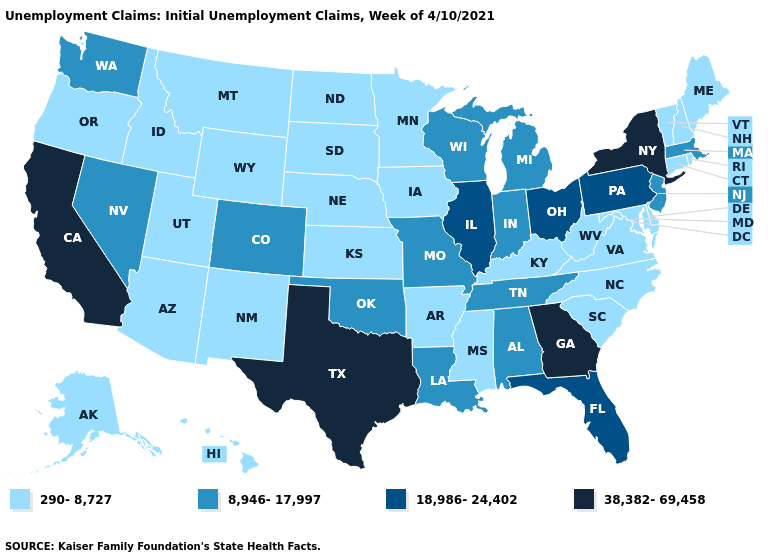Name the states that have a value in the range 290-8,727?
Short answer required. Alaska, Arizona, Arkansas, Connecticut, Delaware, Hawaii, Idaho, Iowa, Kansas, Kentucky, Maine, Maryland, Minnesota, Mississippi, Montana, Nebraska, New Hampshire, New Mexico, North Carolina, North Dakota, Oregon, Rhode Island, South Carolina, South Dakota, Utah, Vermont, Virginia, West Virginia, Wyoming. Does Louisiana have the highest value in the USA?
Answer briefly. No. Name the states that have a value in the range 8,946-17,997?
Concise answer only. Alabama, Colorado, Indiana, Louisiana, Massachusetts, Michigan, Missouri, Nevada, New Jersey, Oklahoma, Tennessee, Washington, Wisconsin. What is the value of South Carolina?
Answer briefly. 290-8,727. What is the value of Connecticut?
Keep it brief. 290-8,727. Among the states that border Minnesota , does Wisconsin have the highest value?
Be succinct. Yes. Which states have the lowest value in the USA?
Give a very brief answer. Alaska, Arizona, Arkansas, Connecticut, Delaware, Hawaii, Idaho, Iowa, Kansas, Kentucky, Maine, Maryland, Minnesota, Mississippi, Montana, Nebraska, New Hampshire, New Mexico, North Carolina, North Dakota, Oregon, Rhode Island, South Carolina, South Dakota, Utah, Vermont, Virginia, West Virginia, Wyoming. What is the highest value in states that border Delaware?
Concise answer only. 18,986-24,402. Is the legend a continuous bar?
Write a very short answer. No. Name the states that have a value in the range 38,382-69,458?
Answer briefly. California, Georgia, New York, Texas. Name the states that have a value in the range 38,382-69,458?
Concise answer only. California, Georgia, New York, Texas. What is the lowest value in the West?
Concise answer only. 290-8,727. How many symbols are there in the legend?
Write a very short answer. 4. Among the states that border Arkansas , which have the lowest value?
Concise answer only. Mississippi. What is the value of North Carolina?
Give a very brief answer. 290-8,727. 